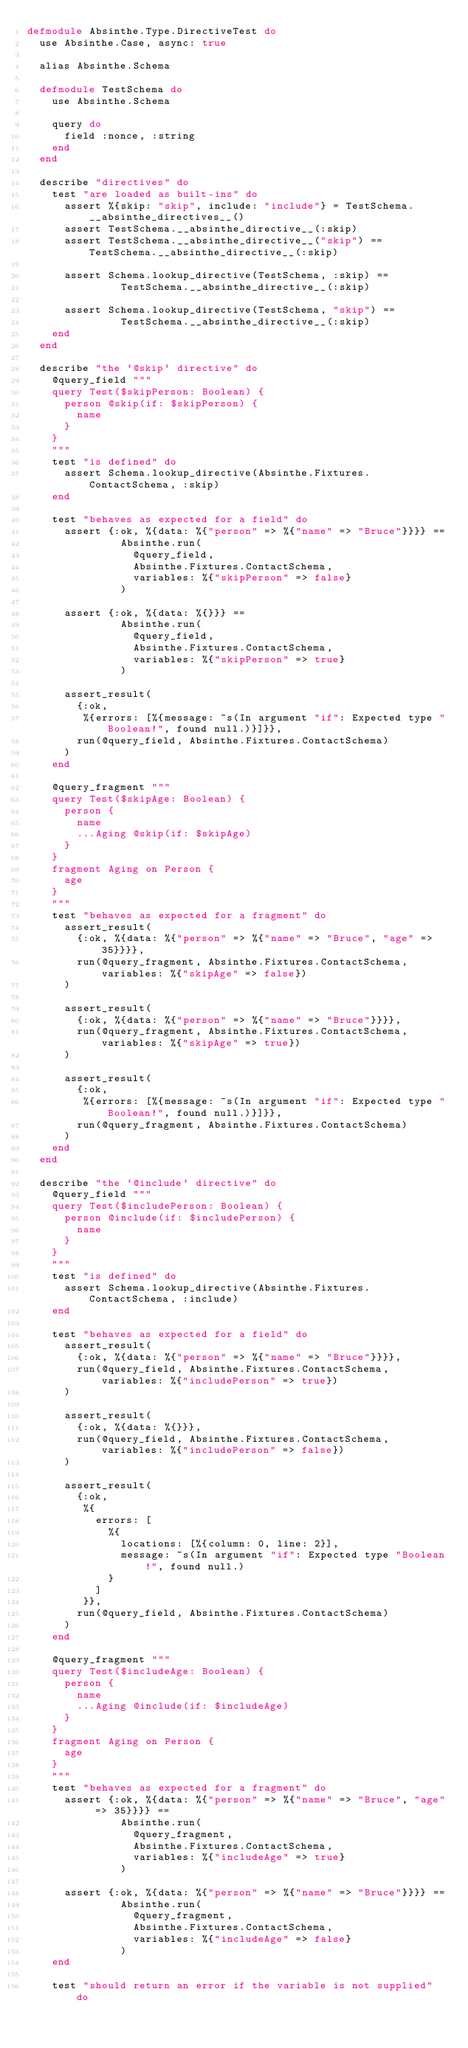<code> <loc_0><loc_0><loc_500><loc_500><_Elixir_>defmodule Absinthe.Type.DirectiveTest do
  use Absinthe.Case, async: true

  alias Absinthe.Schema

  defmodule TestSchema do
    use Absinthe.Schema

    query do
      field :nonce, :string
    end
  end

  describe "directives" do
    test "are loaded as built-ins" do
      assert %{skip: "skip", include: "include"} = TestSchema.__absinthe_directives__()
      assert TestSchema.__absinthe_directive__(:skip)
      assert TestSchema.__absinthe_directive__("skip") == TestSchema.__absinthe_directive__(:skip)

      assert Schema.lookup_directive(TestSchema, :skip) ==
               TestSchema.__absinthe_directive__(:skip)

      assert Schema.lookup_directive(TestSchema, "skip") ==
               TestSchema.__absinthe_directive__(:skip)
    end
  end

  describe "the `@skip` directive" do
    @query_field """
    query Test($skipPerson: Boolean) {
      person @skip(if: $skipPerson) {
        name
      }
    }
    """
    test "is defined" do
      assert Schema.lookup_directive(Absinthe.Fixtures.ContactSchema, :skip)
    end

    test "behaves as expected for a field" do
      assert {:ok, %{data: %{"person" => %{"name" => "Bruce"}}}} ==
               Absinthe.run(
                 @query_field,
                 Absinthe.Fixtures.ContactSchema,
                 variables: %{"skipPerson" => false}
               )

      assert {:ok, %{data: %{}}} ==
               Absinthe.run(
                 @query_field,
                 Absinthe.Fixtures.ContactSchema,
                 variables: %{"skipPerson" => true}
               )

      assert_result(
        {:ok,
         %{errors: [%{message: ~s(In argument "if": Expected type "Boolean!", found null.)}]}},
        run(@query_field, Absinthe.Fixtures.ContactSchema)
      )
    end

    @query_fragment """
    query Test($skipAge: Boolean) {
      person {
        name
        ...Aging @skip(if: $skipAge)
      }
    }
    fragment Aging on Person {
      age
    }
    """
    test "behaves as expected for a fragment" do
      assert_result(
        {:ok, %{data: %{"person" => %{"name" => "Bruce", "age" => 35}}}},
        run(@query_fragment, Absinthe.Fixtures.ContactSchema, variables: %{"skipAge" => false})
      )

      assert_result(
        {:ok, %{data: %{"person" => %{"name" => "Bruce"}}}},
        run(@query_fragment, Absinthe.Fixtures.ContactSchema, variables: %{"skipAge" => true})
      )

      assert_result(
        {:ok,
         %{errors: [%{message: ~s(In argument "if": Expected type "Boolean!", found null.)}]}},
        run(@query_fragment, Absinthe.Fixtures.ContactSchema)
      )
    end
  end

  describe "the `@include` directive" do
    @query_field """
    query Test($includePerson: Boolean) {
      person @include(if: $includePerson) {
        name
      }
    }
    """
    test "is defined" do
      assert Schema.lookup_directive(Absinthe.Fixtures.ContactSchema, :include)
    end

    test "behaves as expected for a field" do
      assert_result(
        {:ok, %{data: %{"person" => %{"name" => "Bruce"}}}},
        run(@query_field, Absinthe.Fixtures.ContactSchema, variables: %{"includePerson" => true})
      )

      assert_result(
        {:ok, %{data: %{}}},
        run(@query_field, Absinthe.Fixtures.ContactSchema, variables: %{"includePerson" => false})
      )

      assert_result(
        {:ok,
         %{
           errors: [
             %{
               locations: [%{column: 0, line: 2}],
               message: ~s(In argument "if": Expected type "Boolean!", found null.)
             }
           ]
         }},
        run(@query_field, Absinthe.Fixtures.ContactSchema)
      )
    end

    @query_fragment """
    query Test($includeAge: Boolean) {
      person {
        name
        ...Aging @include(if: $includeAge)
      }
    }
    fragment Aging on Person {
      age
    }
    """
    test "behaves as expected for a fragment" do
      assert {:ok, %{data: %{"person" => %{"name" => "Bruce", "age" => 35}}}} ==
               Absinthe.run(
                 @query_fragment,
                 Absinthe.Fixtures.ContactSchema,
                 variables: %{"includeAge" => true}
               )

      assert {:ok, %{data: %{"person" => %{"name" => "Bruce"}}}} ==
               Absinthe.run(
                 @query_fragment,
                 Absinthe.Fixtures.ContactSchema,
                 variables: %{"includeAge" => false}
               )
    end

    test "should return an error if the variable is not supplied" do</code> 